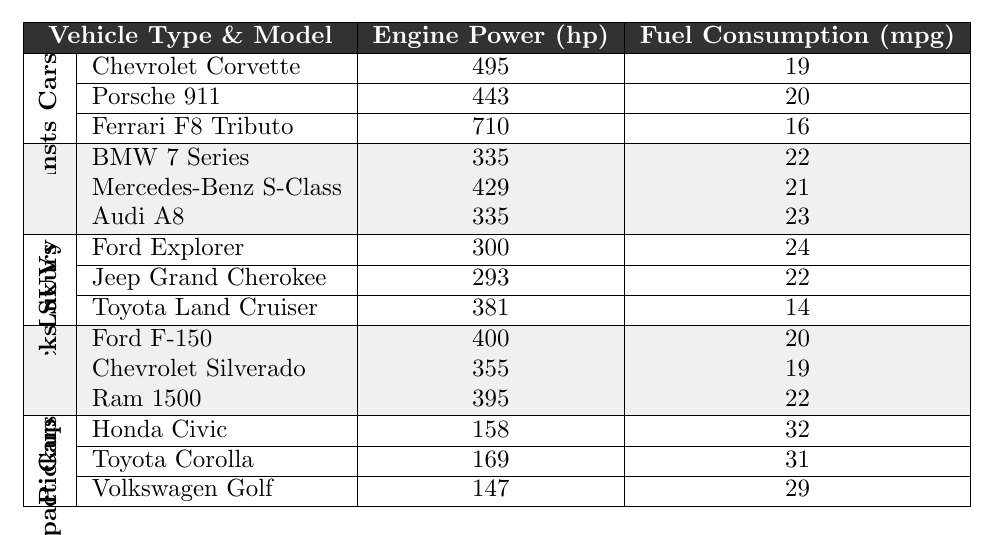What is the engine power of the Porsche 911? The table lists the specifications for the Porsche 911 under the Sports Cars category. Referring to its row, its engine power is noted as 443 hp.
Answer: 443 hp Which vehicle type has the highest fuel consumption? By examining the fuel consumption values, we see SUVs have 24 mpg for the Ford Explorer, which is the highest in the table.
Answer: SUVs What is the average engine power for luxury sedans? The engine power values for luxury sedans (335, 429, and 335 hp) are summed up to get 1099 hp. Then, divided by 3 (the number of models), gives the average as 1099/3 = 366.33 hp.
Answer: 366.33 hp Does the Toyota Land Cruiser have better fuel efficiency than the Chevrolet Silverado? The Toyota Land Cruiser has a fuel consumption of 14 mpg, while the Chevrolet Silverado offers 19 mpg, thus the Silverado is more fuel-efficient.
Answer: No What is the difference in engine power between the fastest sports car and the most powerful luxury sedan? The Ferrari F8 Tributo has an engine power of 710 hp. The most powerful luxury sedan, the Mercedes-Benz S-Class, has 429 hp. The difference is 710 - 429 = 281 hp.
Answer: 281 hp Which type of vehicle has the lowest fuel consumption, and what is that value? By inspecting all vehicle types, we find the Toyota Land Cruiser in the SUVs category has the lowest fuel consumption at 14 mpg.
Answer: SUVs, 14 mpg What is the total engine power of all the sports cars combined? The engine powers for the sports cars are: Chevrolet Corvette (495 hp), Porsche 911 (443 hp), and Ferrari F8 Tributo (710 hp). Adding these values together gives 495 + 443 + 710 = 1648 hp.
Answer: 1648 hp Which compact car has the highest fuel efficiency, and what is that value? Among compact cars, the Honda Civic has the highest fuel consumption at 32 mpg when comparing all three models listed in that category.
Answer: Honda Civic, 32 mpg Is the engine power of the Ford F-150 and Ram 1500 combined greater than that of the Ferrari F8 Tributo? The Ford F-150 has 400 hp and the Ram 1500 has 395 hp, totaling 400 + 395 = 795 hp, which is less than the Ferrari's 710 hp.
Answer: No What is the average fuel consumption across all the vehicle types listed? By summing the fuel consumption values for all vehicles (19, 20, 16, 22, 21, 23, 24, 22, 14, 20, 19, 22, 32, 31, 29) resulting in a total of  22.8 mpg, and dividing by the number of vehicles (15), we find the average is 22.8 mpg.
Answer: 22.8 mpg 